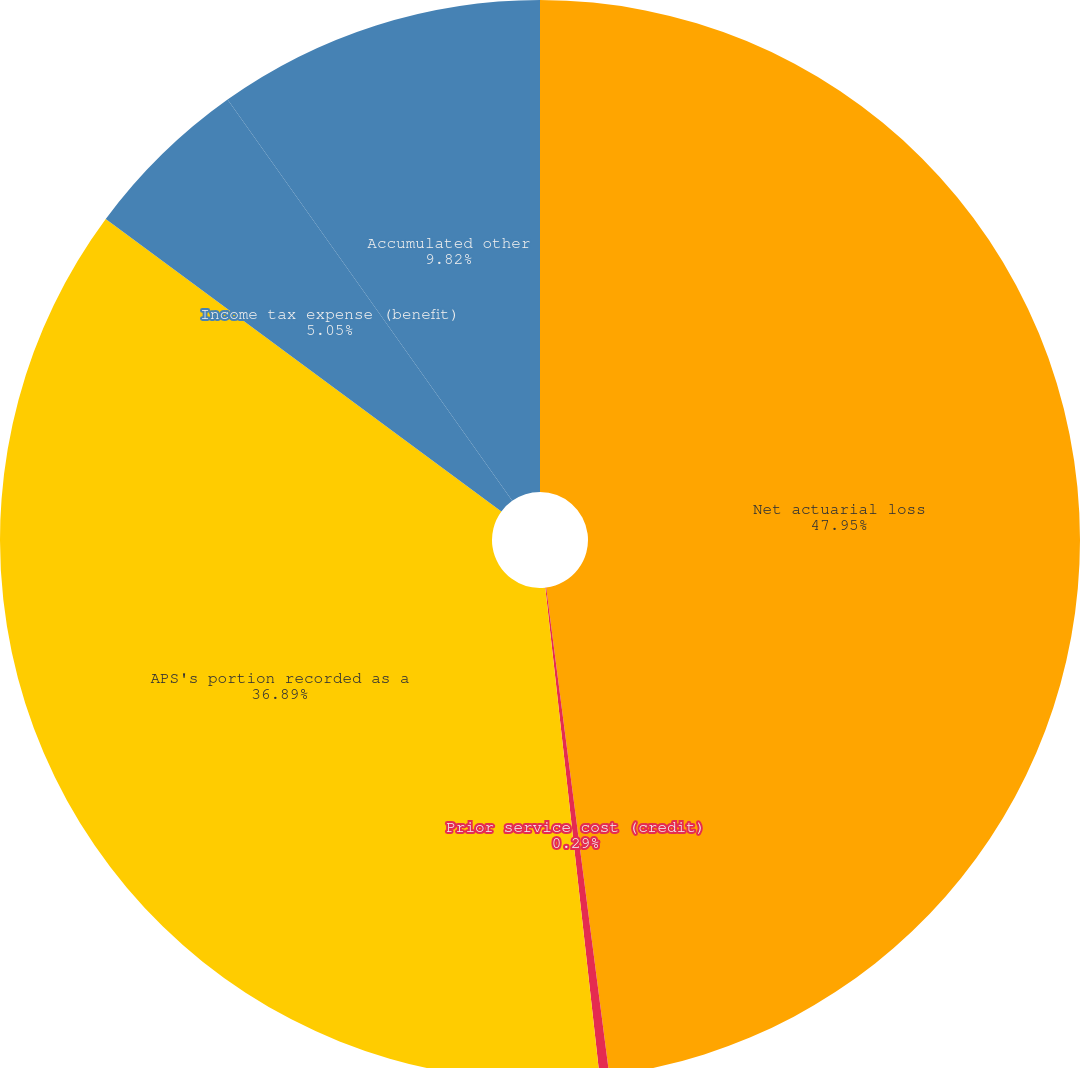Convert chart. <chart><loc_0><loc_0><loc_500><loc_500><pie_chart><fcel>Net actuarial loss<fcel>Prior service cost (credit)<fcel>APS's portion recorded as a<fcel>Income tax expense (benefit)<fcel>Accumulated other<nl><fcel>47.95%<fcel>0.29%<fcel>36.89%<fcel>5.05%<fcel>9.82%<nl></chart> 